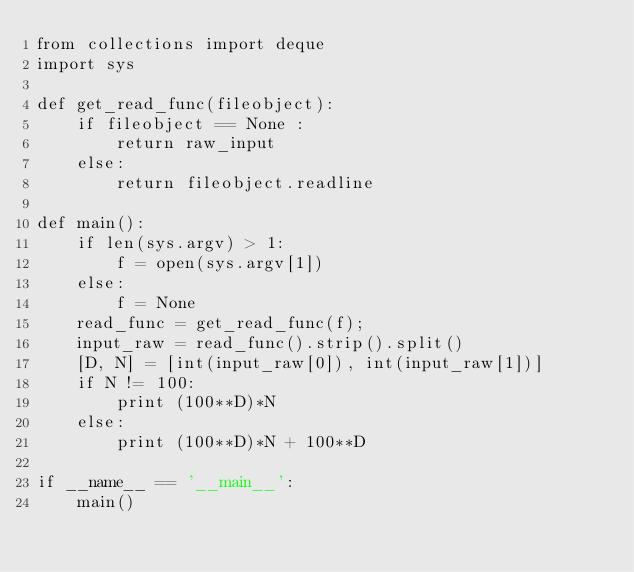<code> <loc_0><loc_0><loc_500><loc_500><_Python_>from collections import deque
import sys

def get_read_func(fileobject):
    if fileobject == None :
        return raw_input
    else:
        return fileobject.readline

def main():
    if len(sys.argv) > 1:
        f = open(sys.argv[1])
    else:
        f = None
    read_func = get_read_func(f);
    input_raw = read_func().strip().split()
    [D, N] = [int(input_raw[0]), int(input_raw[1])]
    if N != 100:
        print (100**D)*N
    else:
        print (100**D)*N + 100**D

if __name__ == '__main__':
    main()</code> 